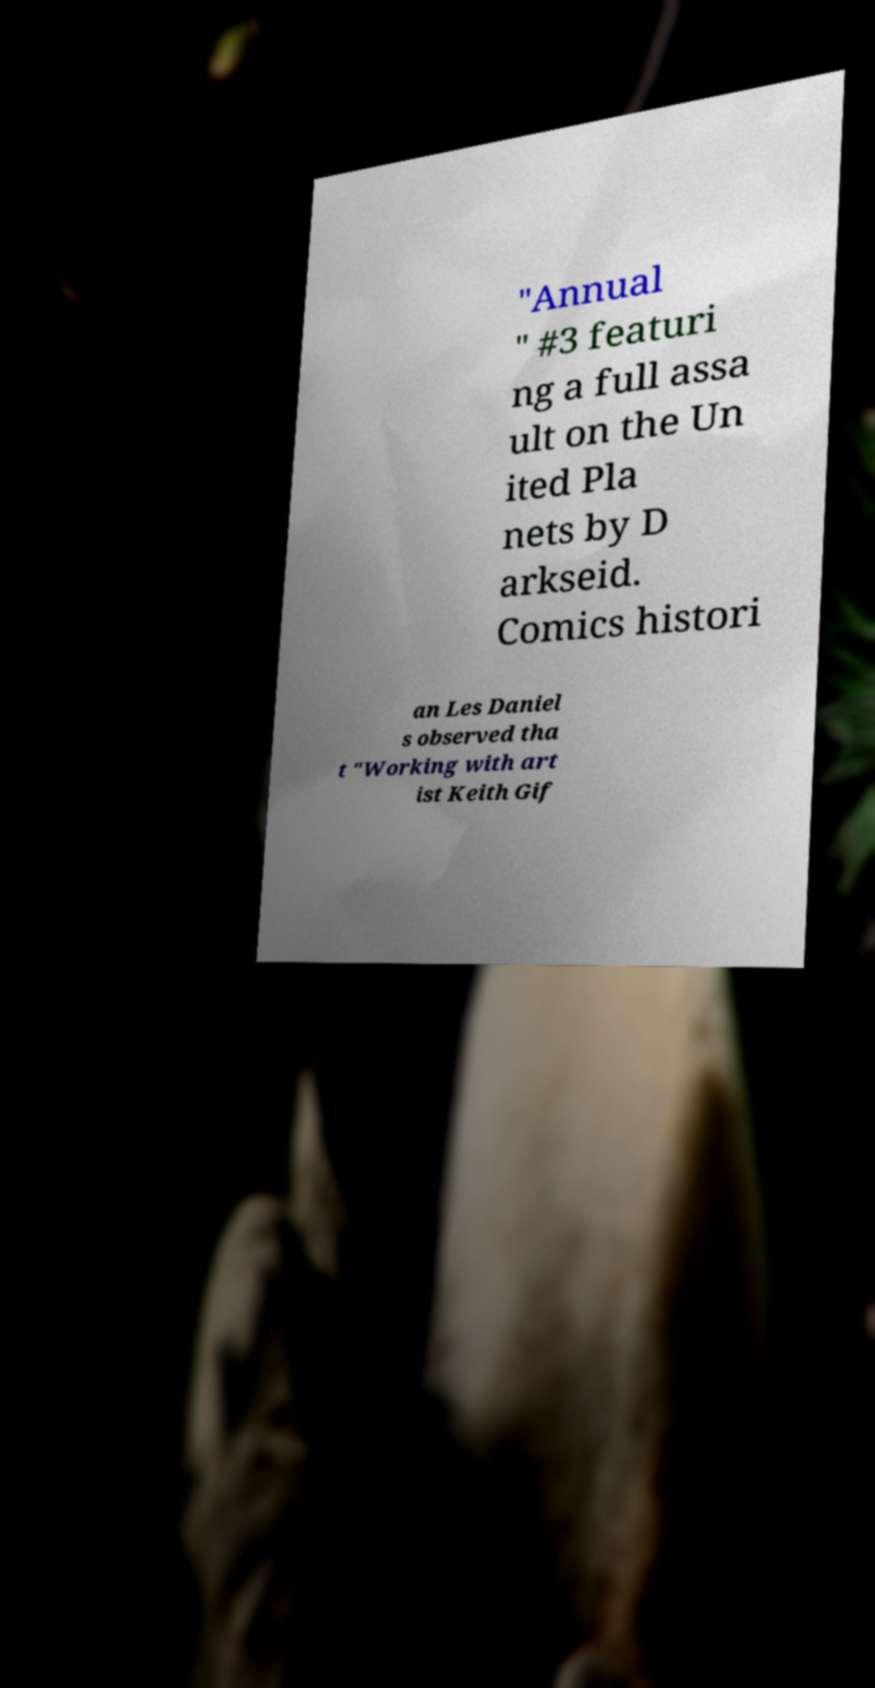There's text embedded in this image that I need extracted. Can you transcribe it verbatim? "Annual " #3 featuri ng a full assa ult on the Un ited Pla nets by D arkseid. Comics histori an Les Daniel s observed tha t "Working with art ist Keith Gif 